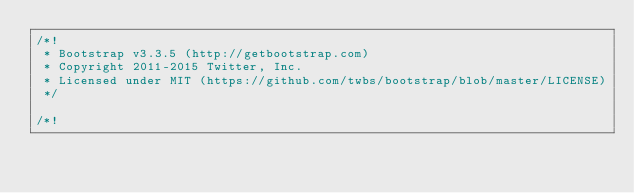Convert code to text. <code><loc_0><loc_0><loc_500><loc_500><_CSS_>/*!
 * Bootstrap v3.3.5 (http://getbootstrap.com)
 * Copyright 2011-2015 Twitter, Inc.
 * Licensed under MIT (https://github.com/twbs/bootstrap/blob/master/LICENSE)
 */

/*!</code> 